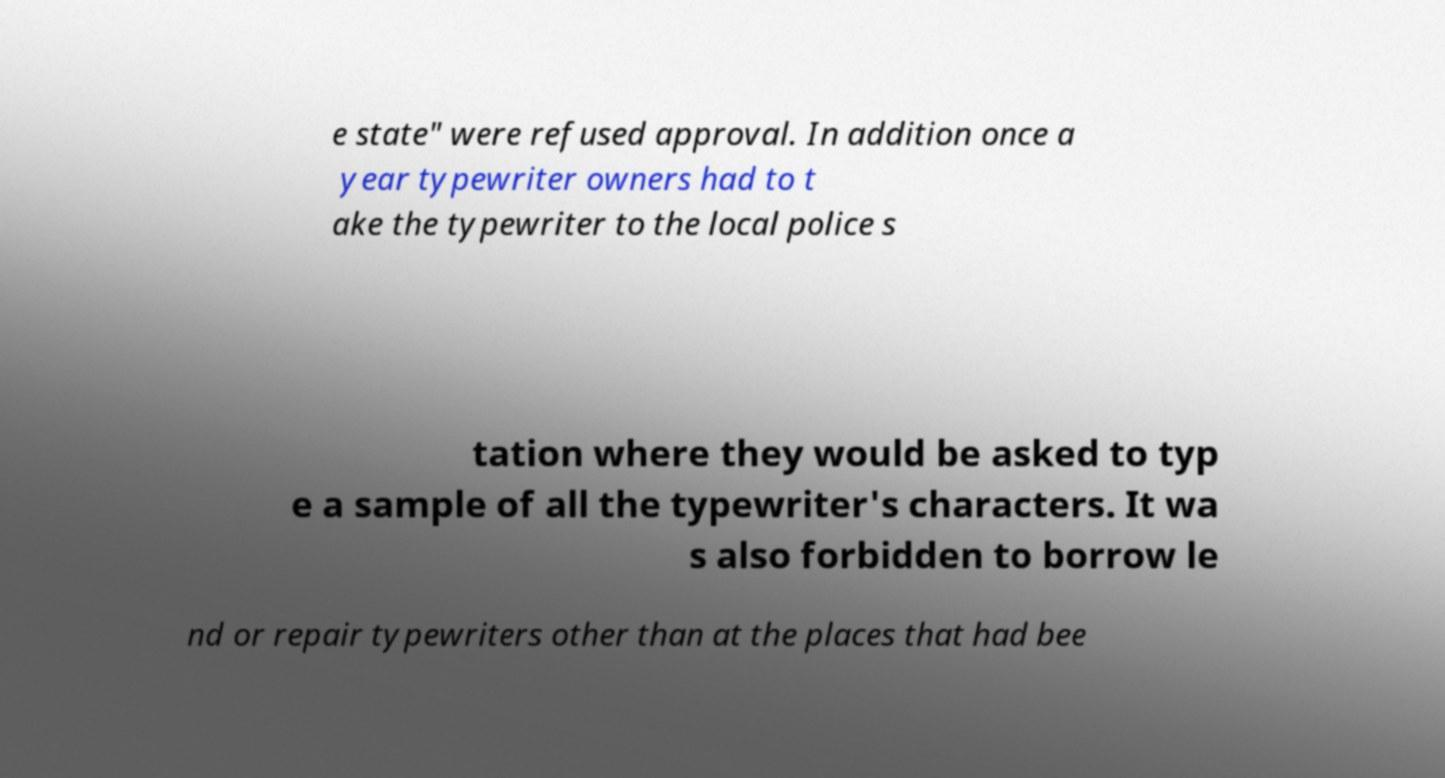There's text embedded in this image that I need extracted. Can you transcribe it verbatim? e state" were refused approval. In addition once a year typewriter owners had to t ake the typewriter to the local police s tation where they would be asked to typ e a sample of all the typewriter's characters. It wa s also forbidden to borrow le nd or repair typewriters other than at the places that had bee 